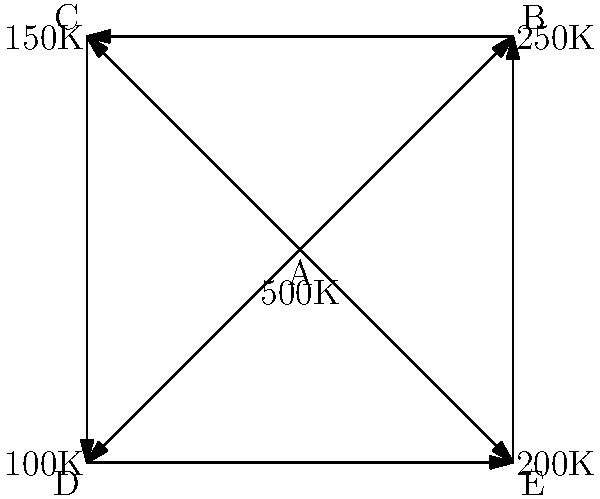In this network diagram of social media influencers, each node represents an influencer, and the arrows indicate follower relationships. The number below each node shows the influencer's follower count. Which influencer has the highest potential reach for a message, considering both direct followers and second-degree connections (followers of followers)? To determine the influencer with the highest potential reach, we need to consider both direct followers and second-degree connections. Let's analyze each influencer:

1. Influencer A:
   - Direct followers: 500K
   - Second-degree connections: 250K + 150K + 100K + 200K = 700K
   - Total potential reach: 500K + 700K = 1,200K

2. Influencer B:
   - Direct followers: 250K
   - Second-degree connections: 500K + 150K + 200K = 850K
   - Total potential reach: 250K + 850K = 1,100K

3. Influencer C:
   - Direct followers: 150K
   - Second-degree connections: 500K + 250K + 100K = 850K
   - Total potential reach: 150K + 850K = 1,000K

4. Influencer D:
   - Direct followers: 100K
   - Second-degree connections: 500K + 150K + 200K = 850K
   - Total potential reach: 100K + 850K = 950K

5. Influencer E:
   - Direct followers: 200K
   - Second-degree connections: 500K + 250K + 100K = 850K
   - Total potential reach: 200K + 850K = 1,050K

Comparing the total potential reach for each influencer, we can see that Influencer A has the highest potential reach at 1,200K.
Answer: Influencer A 